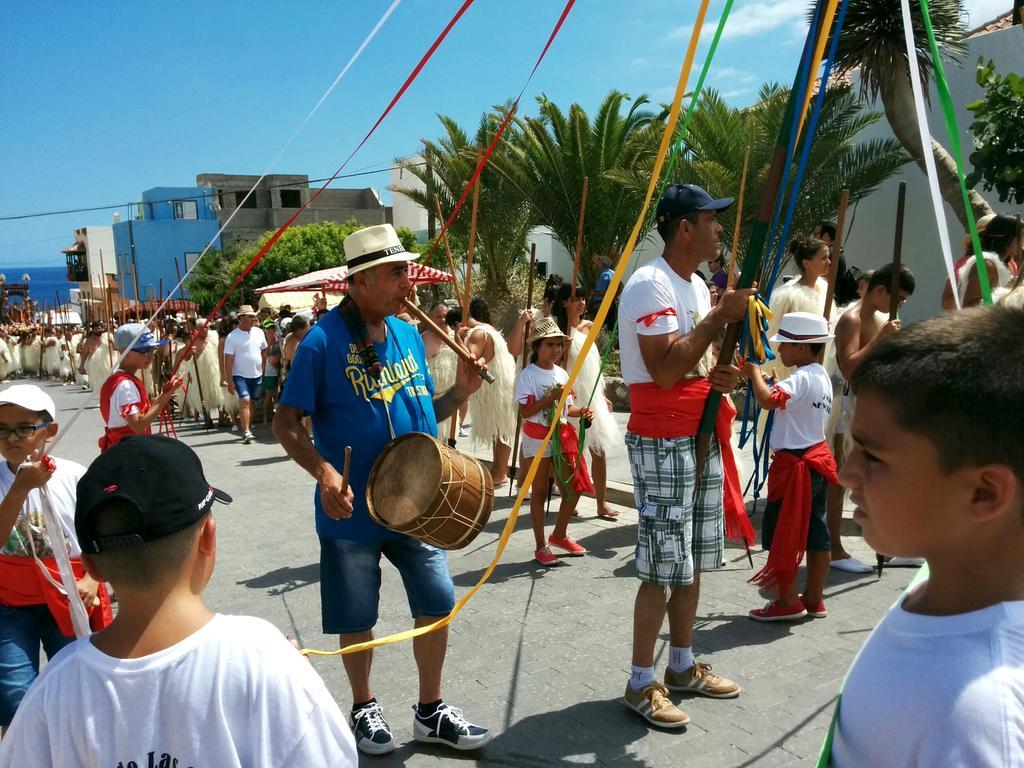Can you describe this image briefly? In this image I can see number of people are standing and few of them are holding musical instruments. I can also see most of them are wearing same color of dresses and few of them are wearing caps. In the background I can see buildings, trees and sky. 